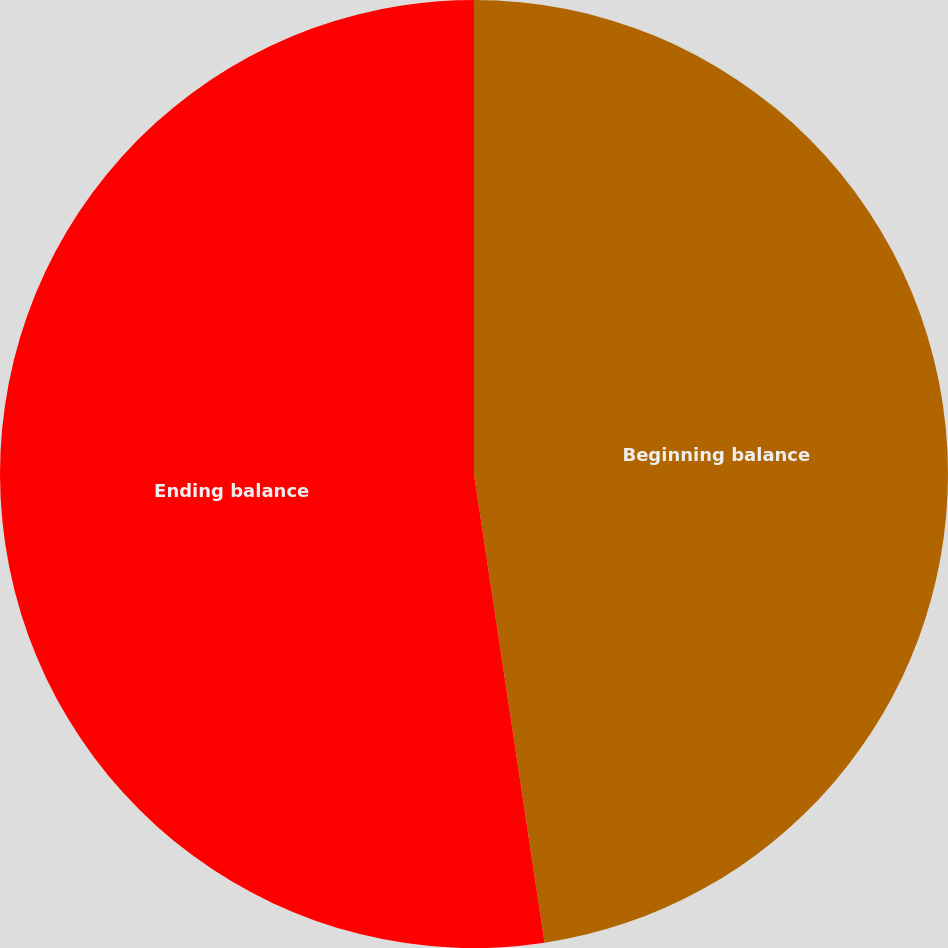Convert chart. <chart><loc_0><loc_0><loc_500><loc_500><pie_chart><fcel>Beginning balance<fcel>Ending balance<nl><fcel>47.62%<fcel>52.38%<nl></chart> 